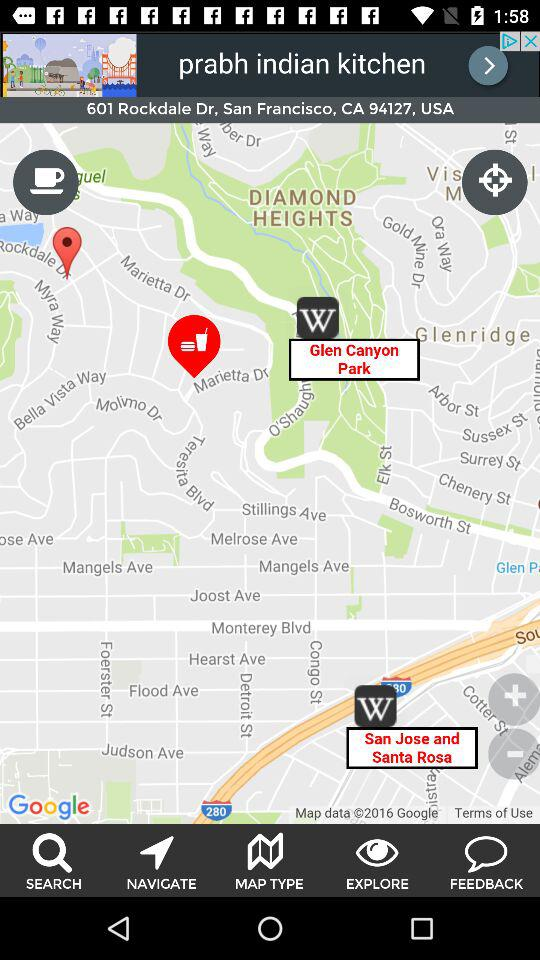What is the mentioned location? The mentioned location is 601 Rockdale Drive, San Francisco, CA 94127, USA. 